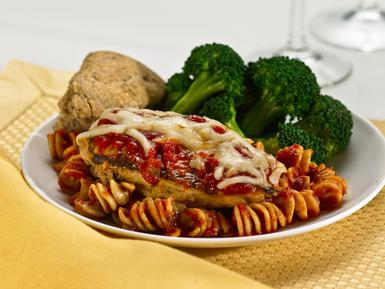Question: when would this be served?
Choices:
A. For breakfast.
B. For lunch.
C. For brunch.
D. For dinner.
Answer with the letter. Answer: D Question: how is it being served?
Choices:
A. With gravy.
B. With salad.
C. With rice and beans.
D. On a plate.
Answer with the letter. Answer: D 